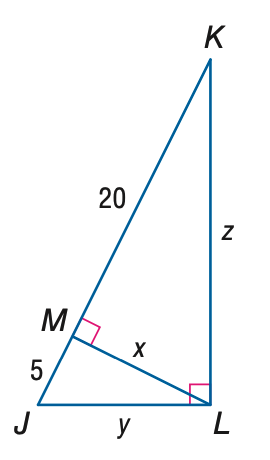Answer the mathemtical geometry problem and directly provide the correct option letter.
Question: Find x.
Choices: A: 5 B: 10 C: 20 D: 100 B 